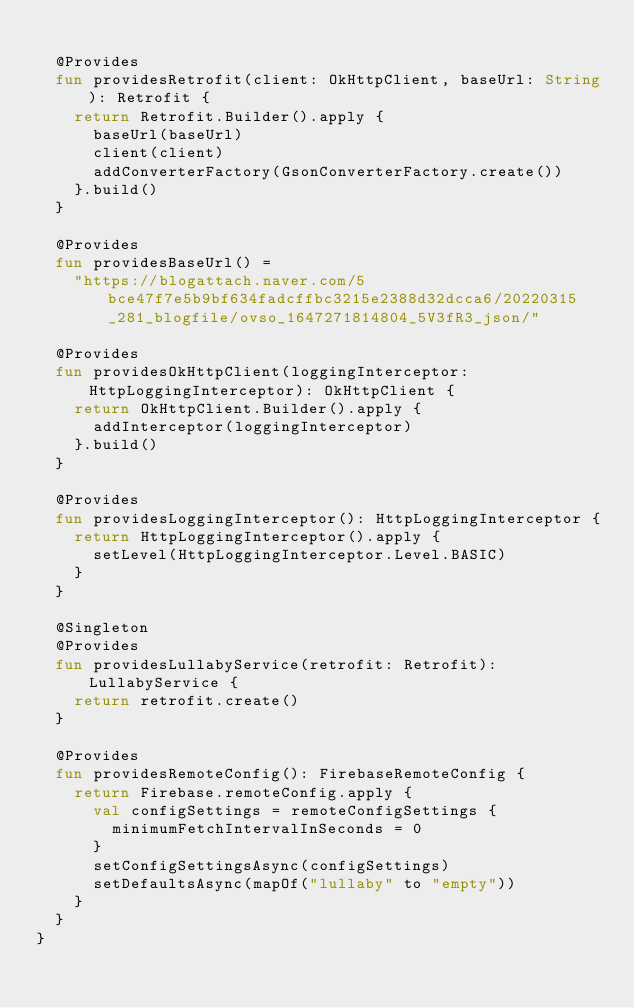<code> <loc_0><loc_0><loc_500><loc_500><_Kotlin_>
  @Provides
  fun providesRetrofit(client: OkHttpClient, baseUrl: String): Retrofit {
    return Retrofit.Builder().apply {
      baseUrl(baseUrl)
      client(client)
      addConverterFactory(GsonConverterFactory.create())
    }.build()
  }

  @Provides
  fun providesBaseUrl() =
    "https://blogattach.naver.com/5bce47f7e5b9bf634fadcffbc3215e2388d32dcca6/20220315_281_blogfile/ovso_1647271814804_5V3fR3_json/"

  @Provides
  fun providesOkHttpClient(loggingInterceptor: HttpLoggingInterceptor): OkHttpClient {
    return OkHttpClient.Builder().apply {
      addInterceptor(loggingInterceptor)
    }.build()
  }

  @Provides
  fun providesLoggingInterceptor(): HttpLoggingInterceptor {
    return HttpLoggingInterceptor().apply {
      setLevel(HttpLoggingInterceptor.Level.BASIC)
    }
  }

  @Singleton
  @Provides
  fun providesLullabyService(retrofit: Retrofit): LullabyService {
    return retrofit.create()
  }

  @Provides
  fun providesRemoteConfig(): FirebaseRemoteConfig {
    return Firebase.remoteConfig.apply {
      val configSettings = remoteConfigSettings {
        minimumFetchIntervalInSeconds = 0
      }
      setConfigSettingsAsync(configSettings)
      setDefaultsAsync(mapOf("lullaby" to "empty"))
    }
  }
}
</code> 